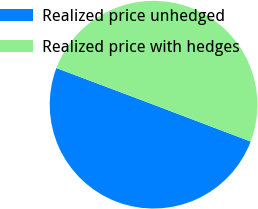<chart> <loc_0><loc_0><loc_500><loc_500><pie_chart><fcel>Realized price unhedged<fcel>Realized price with hedges<nl><fcel>49.96%<fcel>50.04%<nl></chart> 